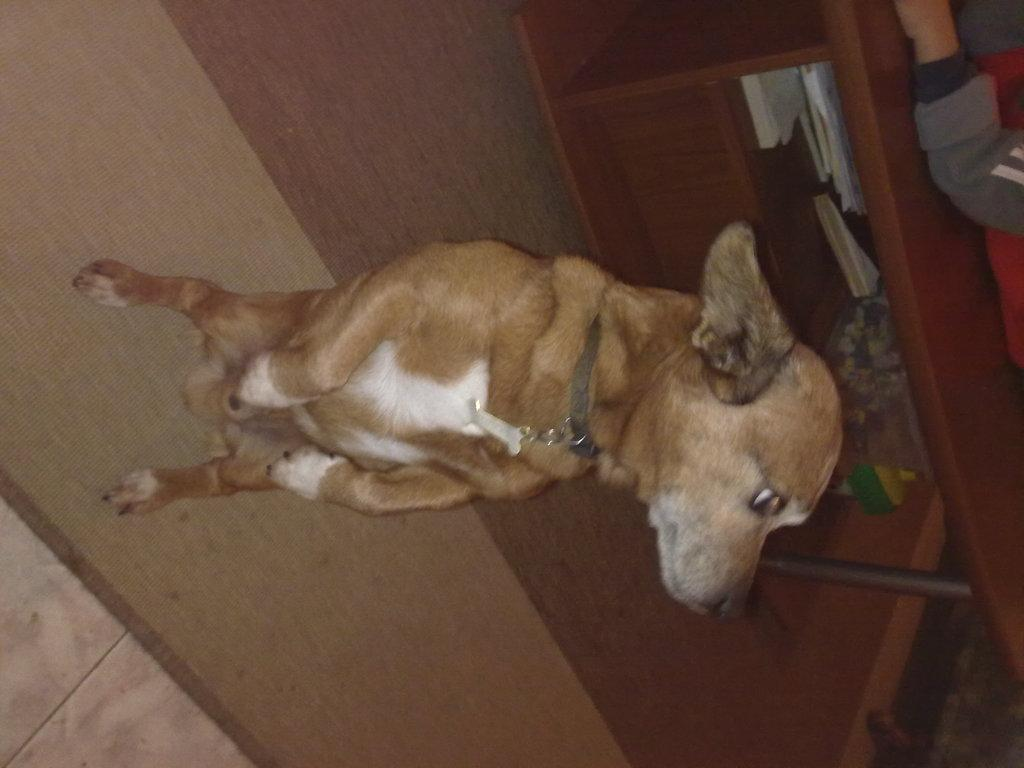What is the main subject in the foreground of the image? There is a dog in the foreground of the image. What is the dog doing in the image? The dog is standing on the floor. What can be seen in the background of the image? There is a man on a table and objects on a shelf in the background of the image. What type of bun is the dog holding in its mouth in the image? There is no bun present in the image; the dog is standing on the floor without holding anything in its mouth. 